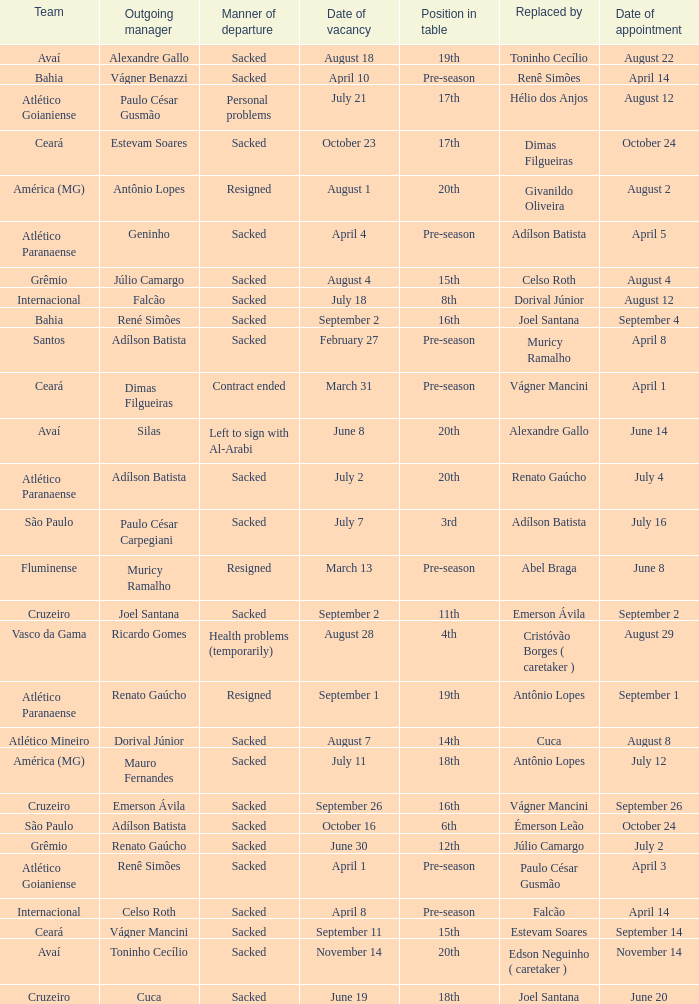Who was the new Santos manager? Muricy Ramalho. 